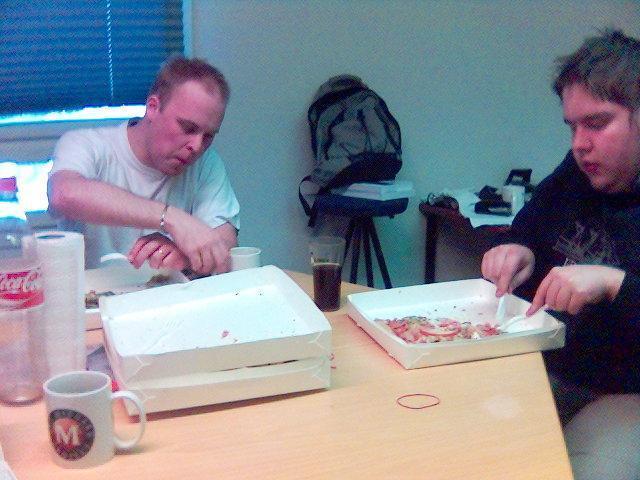How many people are there?
Give a very brief answer. 2. How many cups are there?
Give a very brief answer. 2. How many scissors are in blue color?
Give a very brief answer. 0. 